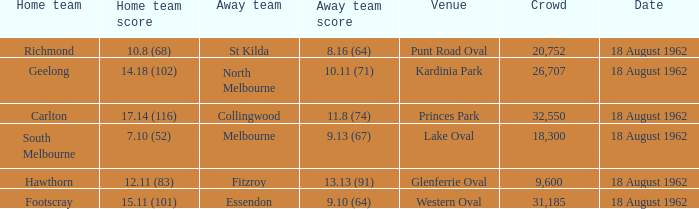8 (68)? St Kilda. 